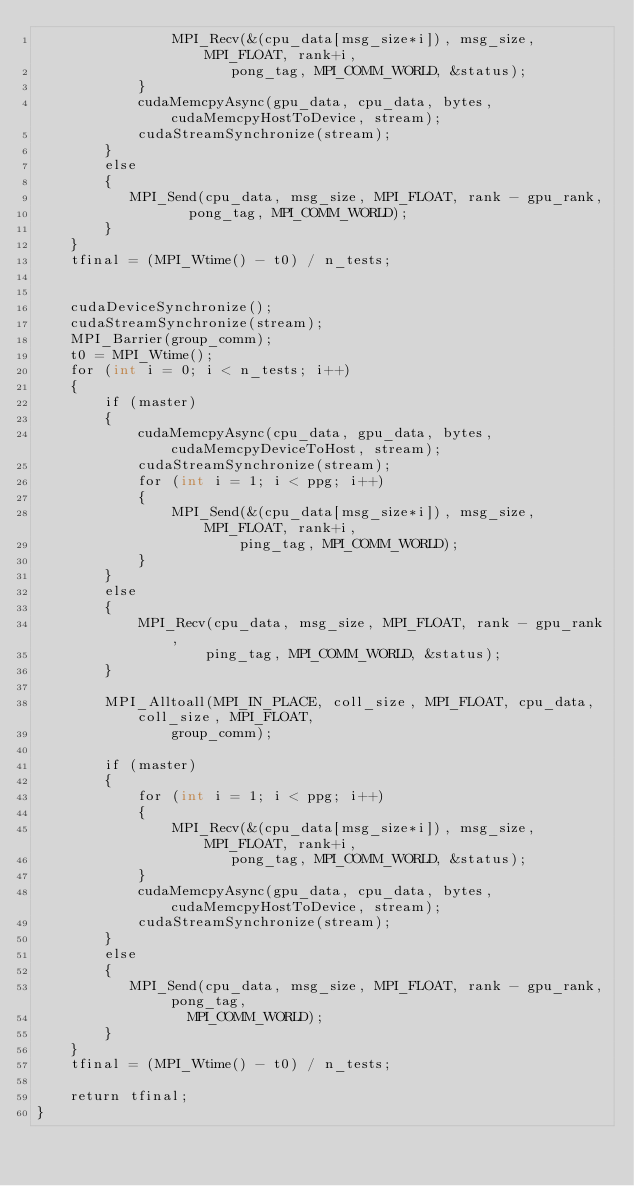<code> <loc_0><loc_0><loc_500><loc_500><_Cuda_>                MPI_Recv(&(cpu_data[msg_size*i]), msg_size, MPI_FLOAT, rank+i, 
                       pong_tag, MPI_COMM_WORLD, &status);
            }
            cudaMemcpyAsync(gpu_data, cpu_data, bytes, cudaMemcpyHostToDevice, stream);
            cudaStreamSynchronize(stream);
        }
        else
        {
           MPI_Send(cpu_data, msg_size, MPI_FLOAT, rank - gpu_rank, 
                  pong_tag, MPI_COMM_WORLD); 
        }
    }
    tfinal = (MPI_Wtime() - t0) / n_tests;
    

    cudaDeviceSynchronize();
    cudaStreamSynchronize(stream);
    MPI_Barrier(group_comm);
    t0 = MPI_Wtime();
    for (int i = 0; i < n_tests; i++)
    {
        if (master)
        {
            cudaMemcpyAsync(cpu_data, gpu_data, bytes, cudaMemcpyDeviceToHost, stream);
            cudaStreamSynchronize(stream);
            for (int i = 1; i < ppg; i++)
            {
                MPI_Send(&(cpu_data[msg_size*i]), msg_size, MPI_FLOAT, rank+i, 
                        ping_tag, MPI_COMM_WORLD);
            }
        }
        else
        {
            MPI_Recv(cpu_data, msg_size, MPI_FLOAT, rank - gpu_rank, 
                    ping_tag, MPI_COMM_WORLD, &status);
        }

        MPI_Alltoall(MPI_IN_PLACE, coll_size, MPI_FLOAT, cpu_data, coll_size, MPI_FLOAT,
                group_comm);
      
        if (master)
        {
            for (int i = 1; i < ppg; i++)
            {
                MPI_Recv(&(cpu_data[msg_size*i]), msg_size, MPI_FLOAT, rank+i, 
                       pong_tag, MPI_COMM_WORLD, &status);
            }
            cudaMemcpyAsync(gpu_data, cpu_data, bytes, cudaMemcpyHostToDevice, stream);
            cudaStreamSynchronize(stream);
        }
        else
        {
           MPI_Send(cpu_data, msg_size, MPI_FLOAT, rank - gpu_rank, pong_tag,
                  MPI_COMM_WORLD); 
        }
    }
    tfinal = (MPI_Wtime() - t0) / n_tests;

    return tfinal;
}

</code> 